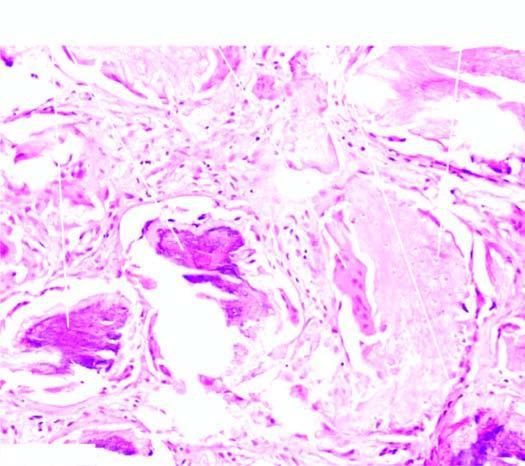re areas of calcification also seen?
Answer the question using a single word or phrase. Yes 